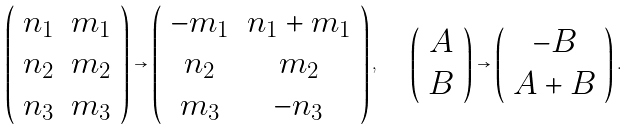<formula> <loc_0><loc_0><loc_500><loc_500>\left ( \begin{array} { c c } n _ { 1 } & m _ { 1 } \\ n _ { 2 } & m _ { 2 } \\ n _ { 3 } & m _ { 3 } \end{array} \right ) \rightarrow \left ( \begin{array} { c c } - m _ { 1 } & n _ { 1 } + m _ { 1 } \\ n _ { 2 } & m _ { 2 } \\ m _ { 3 } & - n _ { 3 } \end{array} \right ) , \quad \left ( \begin{array} { c } A \\ B \end{array} \right ) \rightarrow \left ( \begin{array} { c } - B \\ A + B \end{array} \right ) .</formula> 